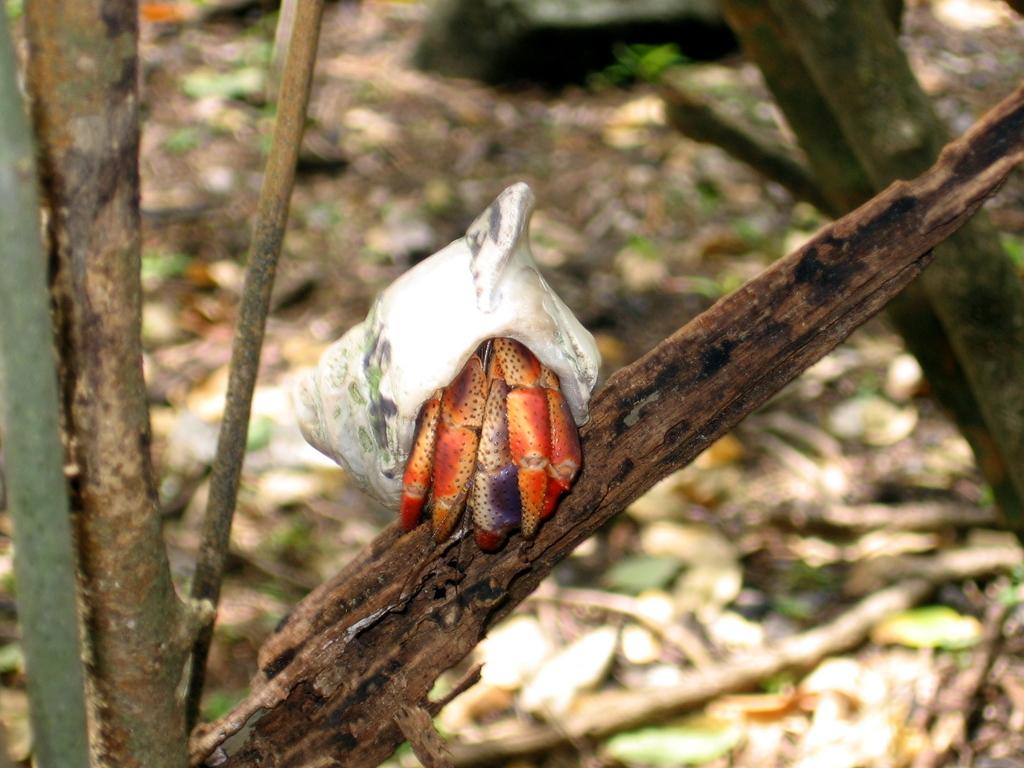What is located on the right side of the image? The branch with an insect on it is located on the right side of the image. Can you describe the insect in the image? Unfortunately, the image does not provide enough detail to describe the insect. What else can be seen in the background of the image? There is trash visible in the background of the image. What type of chalk is being used to draw on the mailbox in the image? There is no mailbox or chalk present in the image. 